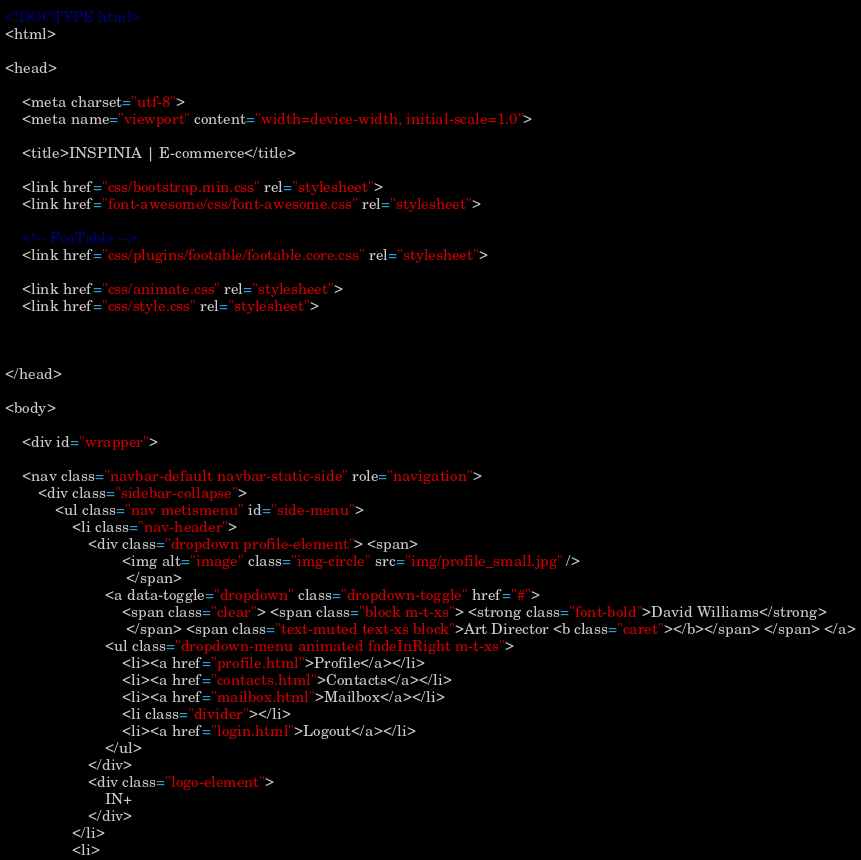Convert code to text. <code><loc_0><loc_0><loc_500><loc_500><_HTML_><!DOCTYPE html>
<html>

<head>

    <meta charset="utf-8">
    <meta name="viewport" content="width=device-width, initial-scale=1.0">

    <title>INSPINIA | E-commerce</title>

    <link href="css/bootstrap.min.css" rel="stylesheet">
    <link href="font-awesome/css/font-awesome.css" rel="stylesheet">

    <!-- FooTable -->
    <link href="css/plugins/footable/footable.core.css" rel="stylesheet">

    <link href="css/animate.css" rel="stylesheet">
    <link href="css/style.css" rel="stylesheet">



</head>

<body>

    <div id="wrapper">

    <nav class="navbar-default navbar-static-side" role="navigation">
        <div class="sidebar-collapse">
            <ul class="nav metismenu" id="side-menu">
                <li class="nav-header">
                    <div class="dropdown profile-element"> <span>
                            <img alt="image" class="img-circle" src="img/profile_small.jpg" />
                             </span>
                        <a data-toggle="dropdown" class="dropdown-toggle" href="#">
                            <span class="clear"> <span class="block m-t-xs"> <strong class="font-bold">David Williams</strong>
                             </span> <span class="text-muted text-xs block">Art Director <b class="caret"></b></span> </span> </a>
                        <ul class="dropdown-menu animated fadeInRight m-t-xs">
                            <li><a href="profile.html">Profile</a></li>
                            <li><a href="contacts.html">Contacts</a></li>
                            <li><a href="mailbox.html">Mailbox</a></li>
                            <li class="divider"></li>
                            <li><a href="login.html">Logout</a></li>
                        </ul>
                    </div>
                    <div class="logo-element">
                        IN+
                    </div>
                </li>
                <li></code> 